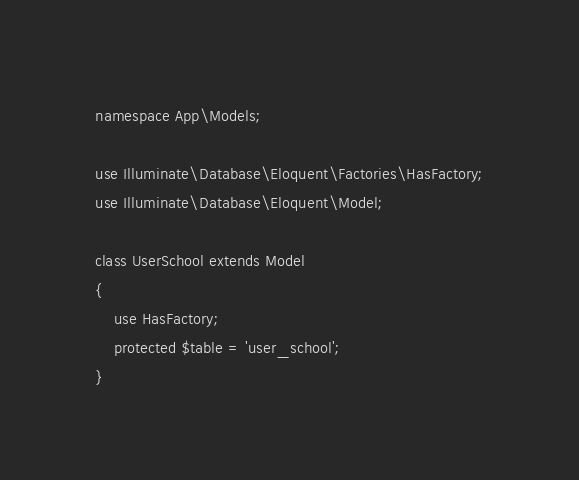<code> <loc_0><loc_0><loc_500><loc_500><_PHP_>
namespace App\Models;

use Illuminate\Database\Eloquent\Factories\HasFactory;
use Illuminate\Database\Eloquent\Model;

class UserSchool extends Model
{
    use HasFactory;
    protected $table = 'user_school';
}
</code> 